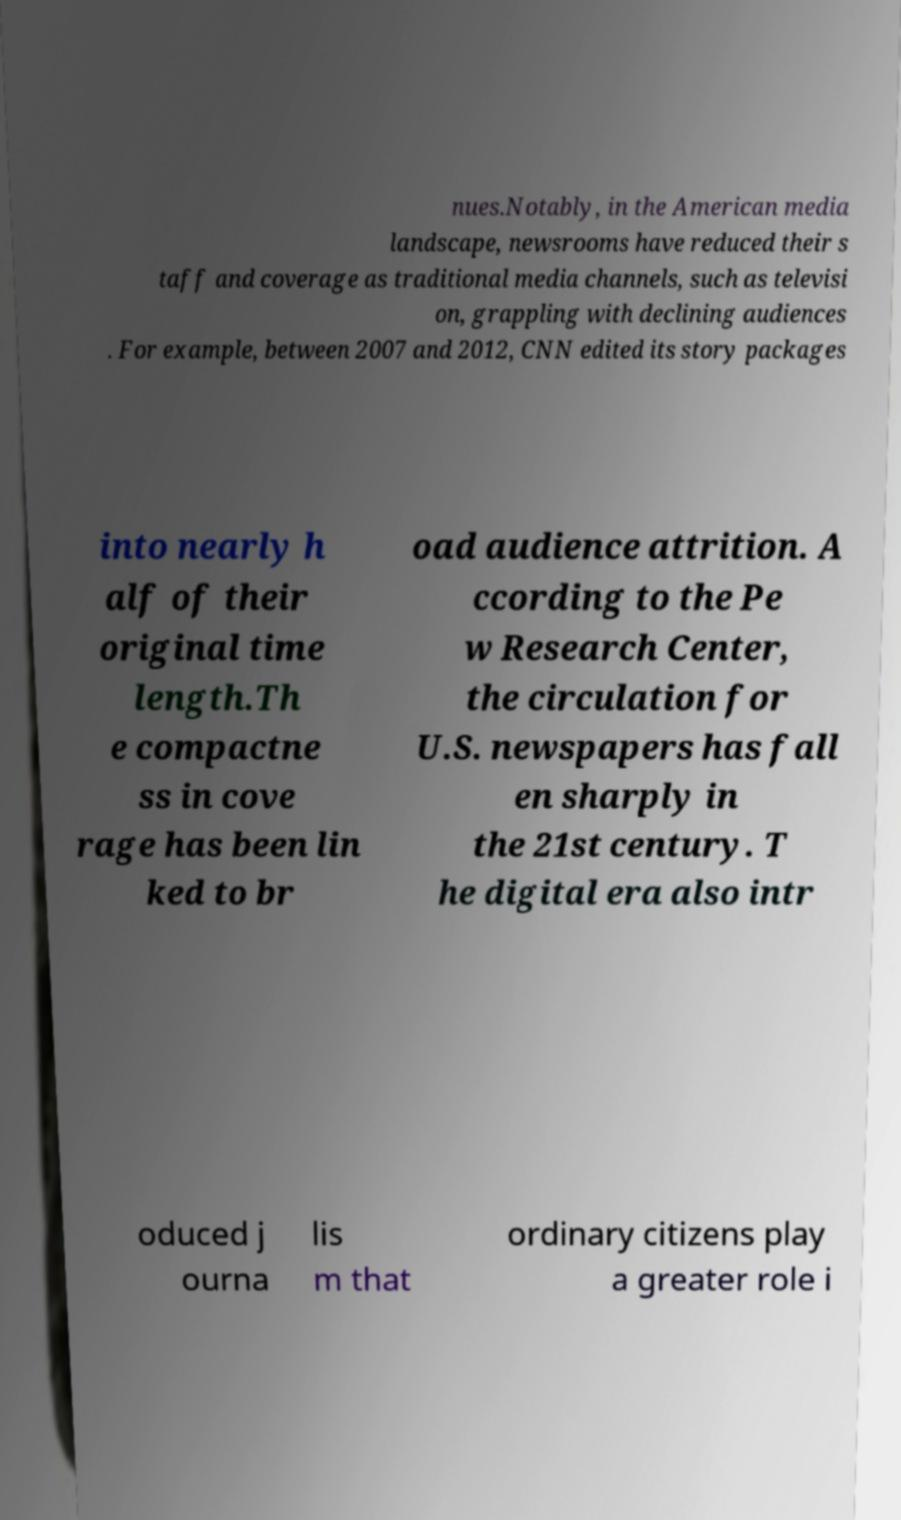For documentation purposes, I need the text within this image transcribed. Could you provide that? nues.Notably, in the American media landscape, newsrooms have reduced their s taff and coverage as traditional media channels, such as televisi on, grappling with declining audiences . For example, between 2007 and 2012, CNN edited its story packages into nearly h alf of their original time length.Th e compactne ss in cove rage has been lin ked to br oad audience attrition. A ccording to the Pe w Research Center, the circulation for U.S. newspapers has fall en sharply in the 21st century. T he digital era also intr oduced j ourna lis m that ordinary citizens play a greater role i 